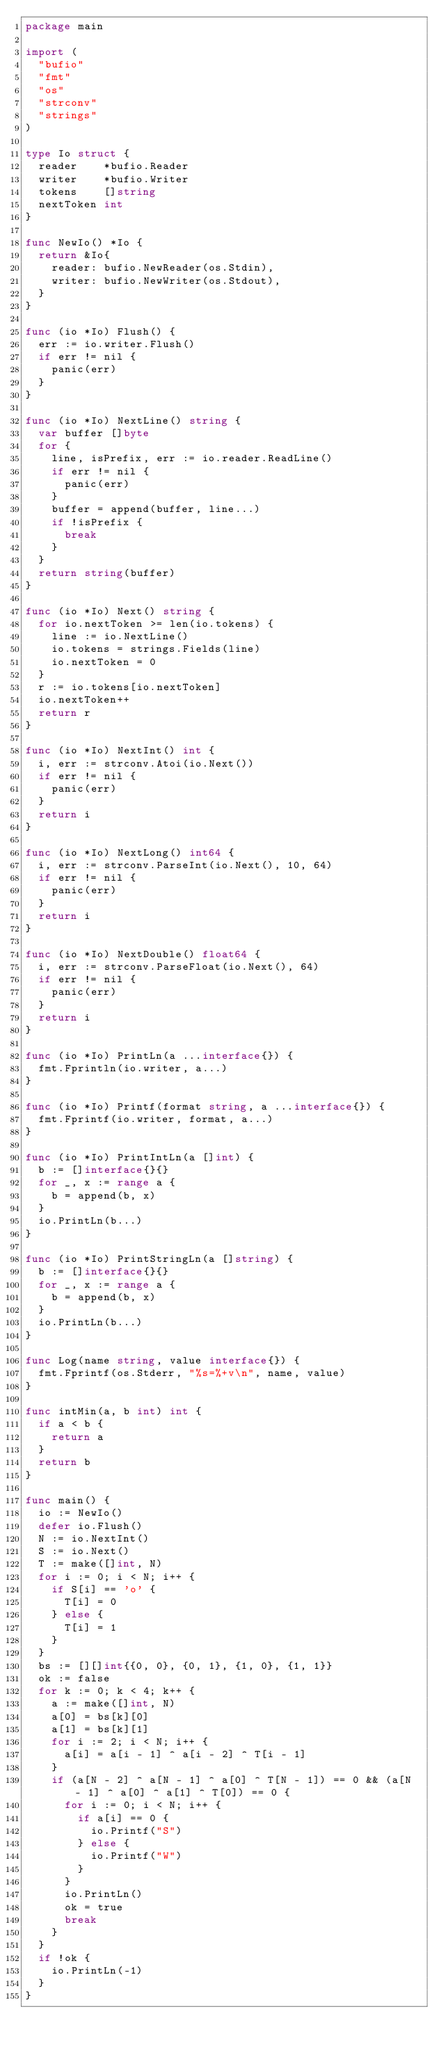Convert code to text. <code><loc_0><loc_0><loc_500><loc_500><_Go_>package main

import (
	"bufio"
	"fmt"
	"os"
	"strconv"
	"strings"
)

type Io struct {
	reader    *bufio.Reader
	writer    *bufio.Writer
	tokens    []string
	nextToken int
}

func NewIo() *Io {
	return &Io{
		reader: bufio.NewReader(os.Stdin),
		writer: bufio.NewWriter(os.Stdout),
	}
}

func (io *Io) Flush() {
	err := io.writer.Flush()
	if err != nil {
		panic(err)
	}
}

func (io *Io) NextLine() string {
	var buffer []byte
	for {
		line, isPrefix, err := io.reader.ReadLine()
		if err != nil {
			panic(err)
		}
		buffer = append(buffer, line...)
		if !isPrefix {
			break
		}
	}
	return string(buffer)
}

func (io *Io) Next() string {
	for io.nextToken >= len(io.tokens) {
		line := io.NextLine()
		io.tokens = strings.Fields(line)
		io.nextToken = 0
	}
	r := io.tokens[io.nextToken]
	io.nextToken++
	return r
}

func (io *Io) NextInt() int {
	i, err := strconv.Atoi(io.Next())
	if err != nil {
		panic(err)
	}
	return i
}

func (io *Io) NextLong() int64 {
	i, err := strconv.ParseInt(io.Next(), 10, 64)
	if err != nil {
		panic(err)
	}
	return i
}

func (io *Io) NextDouble() float64 {
	i, err := strconv.ParseFloat(io.Next(), 64)
	if err != nil {
		panic(err)
	}
	return i
}

func (io *Io) PrintLn(a ...interface{}) {
	fmt.Fprintln(io.writer, a...)
}

func (io *Io) Printf(format string, a ...interface{}) {
	fmt.Fprintf(io.writer, format, a...)
}

func (io *Io) PrintIntLn(a []int) {
	b := []interface{}{}
	for _, x := range a {
		b = append(b, x)
	}
	io.PrintLn(b...)
}

func (io *Io) PrintStringLn(a []string) {
	b := []interface{}{}
	for _, x := range a {
		b = append(b, x)
	}
	io.PrintLn(b...)
}

func Log(name string, value interface{}) {
	fmt.Fprintf(os.Stderr, "%s=%+v\n", name, value)
}

func intMin(a, b int) int {
	if a < b {
		return a
	}
	return b
}

func main() {
	io := NewIo()
	defer io.Flush()
	N := io.NextInt()
	S := io.Next()
	T := make([]int, N)
	for i := 0; i < N; i++ {
		if S[i] == 'o' {
			T[i] = 0
		} else {
			T[i] = 1
		}
	}
	bs := [][]int{{0, 0}, {0, 1}, {1, 0}, {1, 1}}
	ok := false
	for k := 0; k < 4; k++ {
		a := make([]int, N)
		a[0] = bs[k][0]
		a[1] = bs[k][1]
		for i := 2; i < N; i++ {
			a[i] = a[i - 1] ^ a[i - 2] ^ T[i - 1]
		}
		if (a[N - 2] ^ a[N - 1] ^ a[0] ^ T[N - 1]) == 0 && (a[N - 1] ^ a[0] ^ a[1] ^ T[0]) == 0 {
			for i := 0; i < N; i++ {
				if a[i] == 0 {
					io.Printf("S")
				} else {
					io.Printf("W")
				}
			}
			io.PrintLn()
			ok = true
			break
		}
	}
	if !ok {
		io.PrintLn(-1)
	}
}</code> 